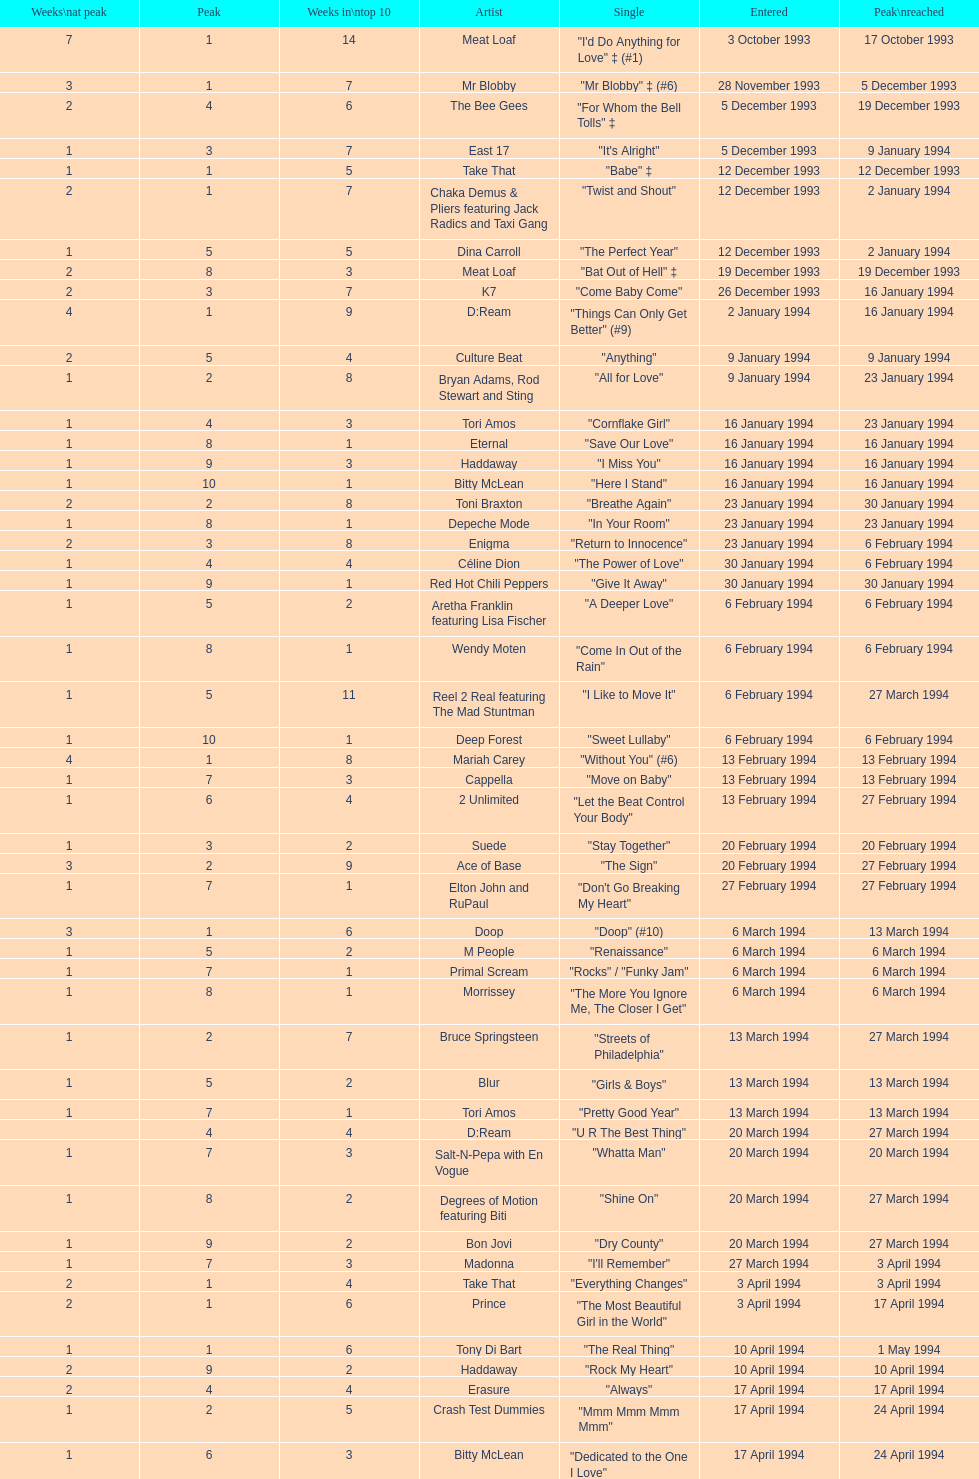What is the first entered date? 3 October 1993. 